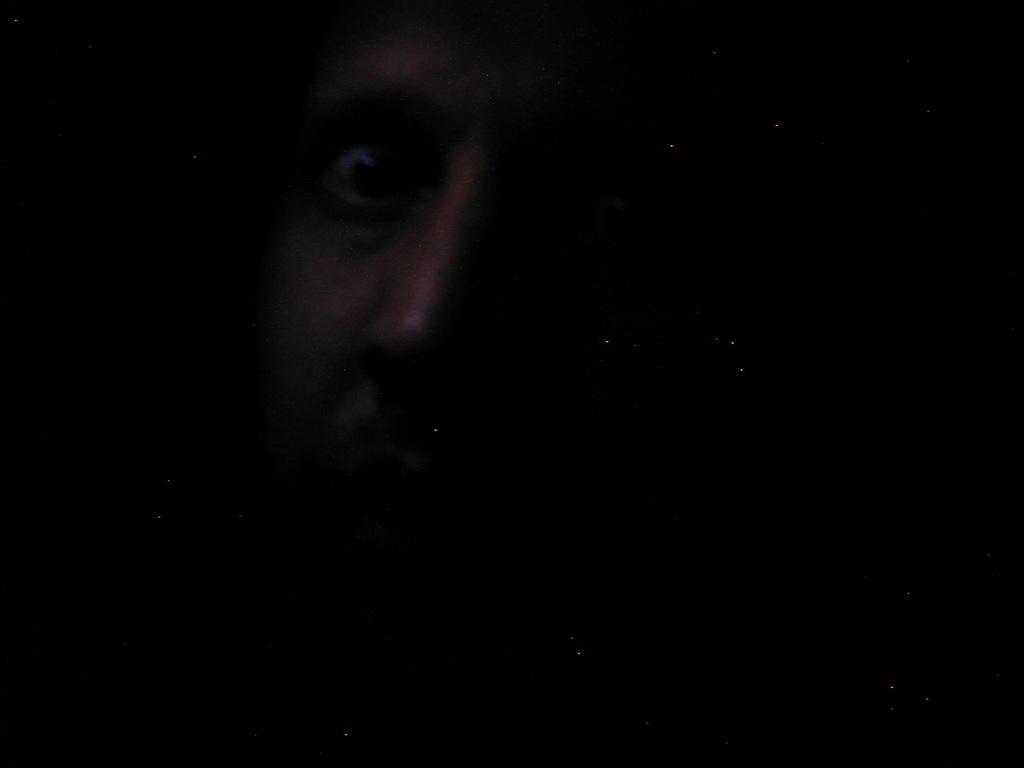How would you summarize this image in a sentence or two? This picture is completely dark and here we can see face of a person. 